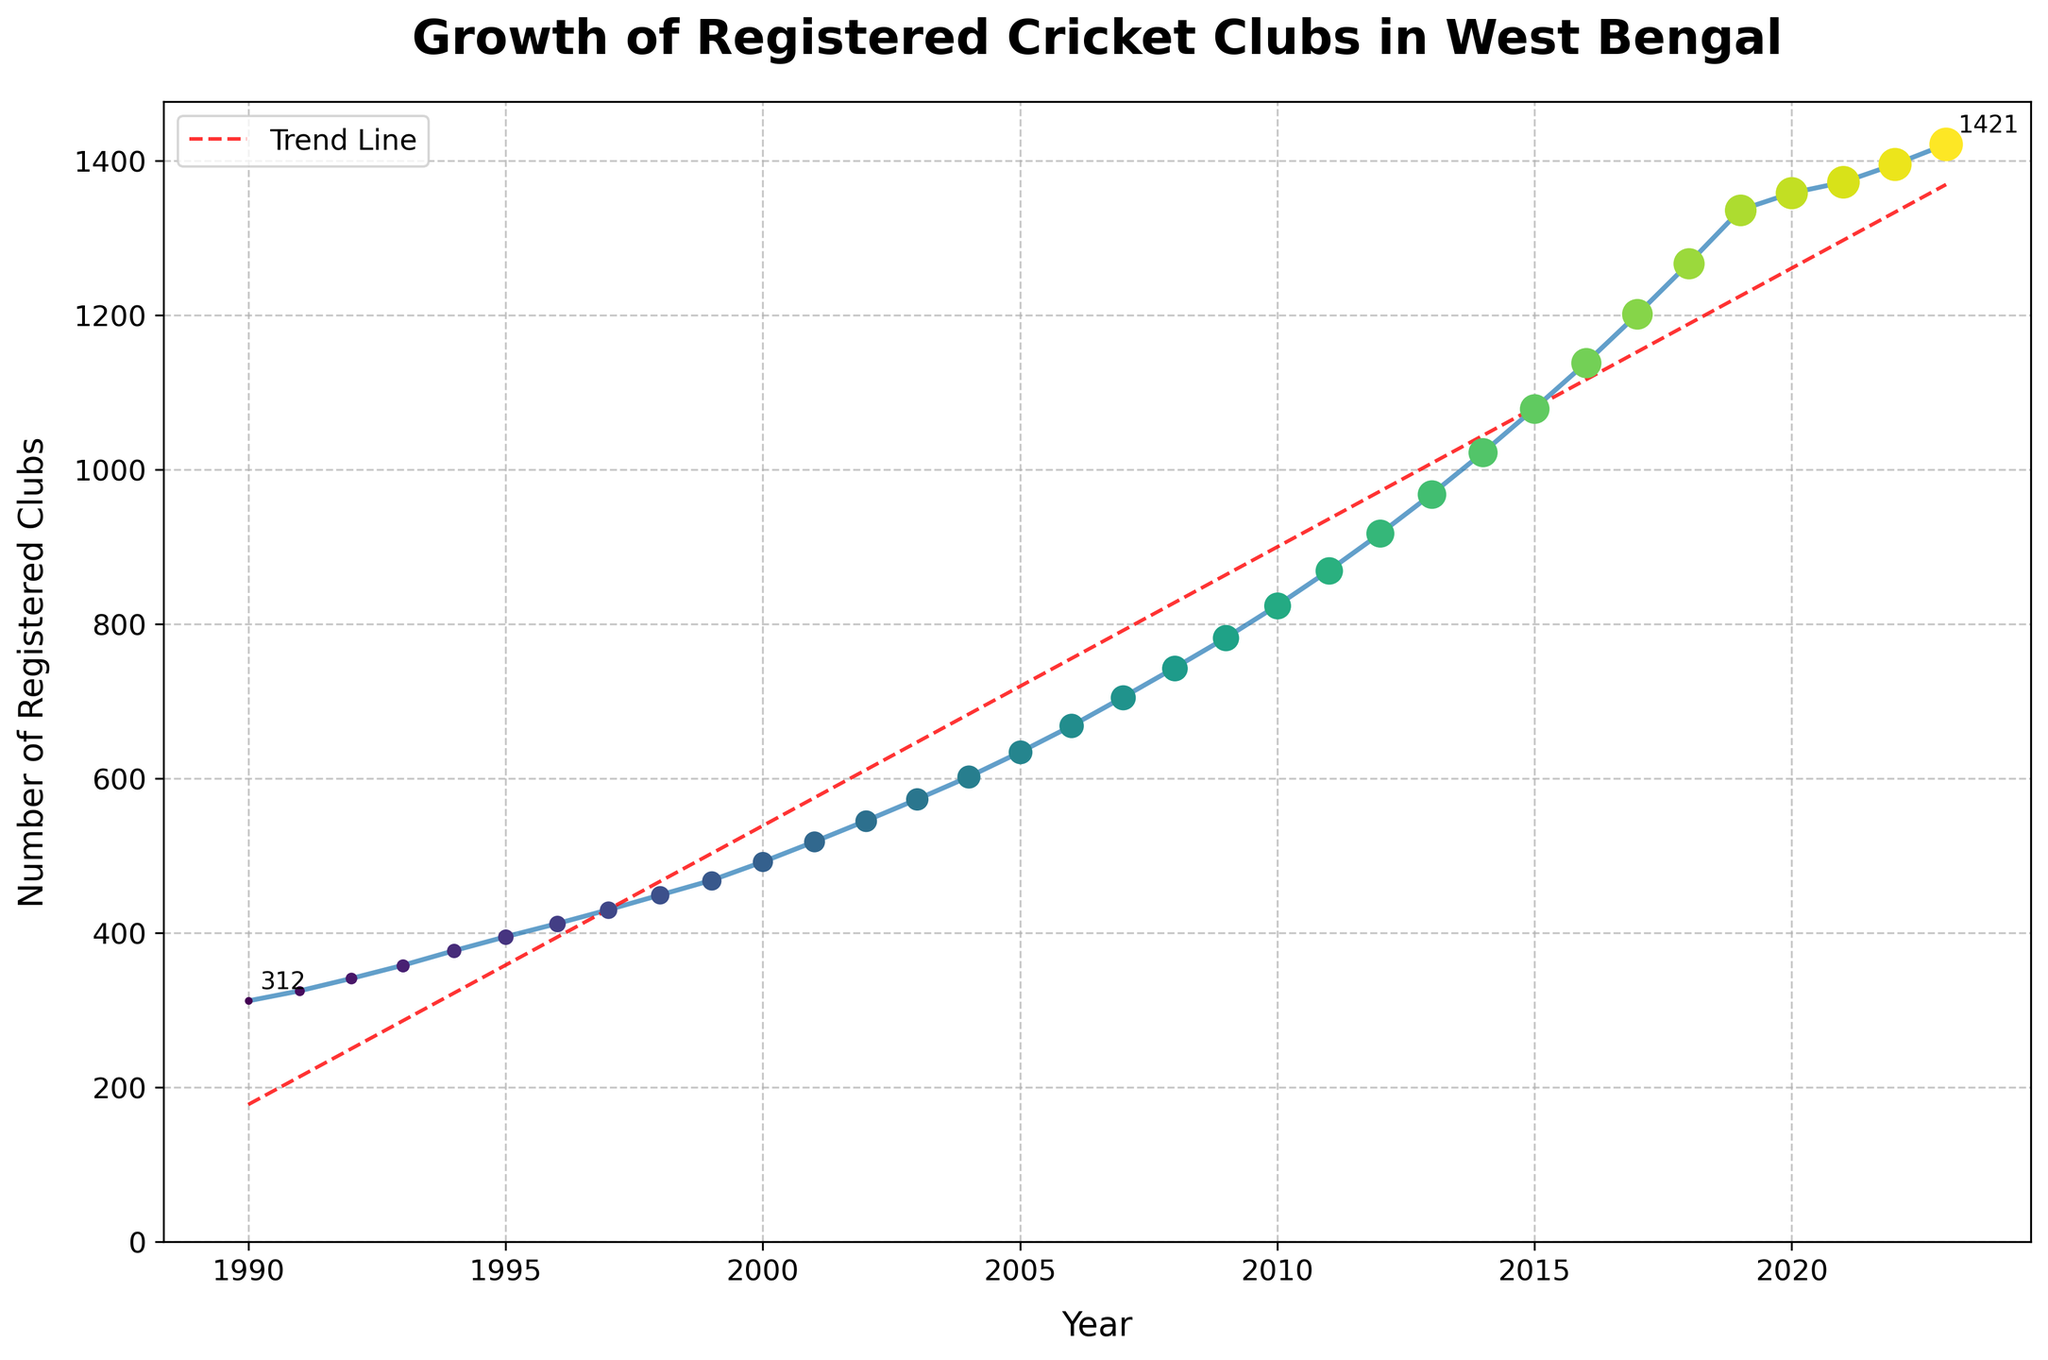What was the number of registered cricket clubs in West Bengal in 1995? To answer this, look at the data point corresponding to the year 1995. The plot shows 395 clubs in 1995.
Answer: 395 What is the percentage growth in the number of registered cricket clubs from 1990 to 2023? Calculate the increase: 1421 - 312 = 1109. Then, divide by the initial number and multiply by 100 to get the percentage: (1109 / 312) * 100 ≈ 355.4%.
Answer: 355.4% Which year saw the highest annual increase in the number of registered cricket clubs? To find the highest annual increase, look at the differences between consecutive years on the plot. The largest difference appears between 2013 (968 clubs) and 2014 (1022 clubs), which is an increase of 54 clubs.
Answer: 2014 How does the trend line compare to the actual data points in terms of the overall growth rate? The trend line generally follows the upward trajectory of the data points, indicating a consistent increase in the number of clubs over the years. Both the line and the data points suggest significant growth, albeit with some variance around the trend line.
Answer: Consistent upward growth What was the average number of registered cricket clubs between 2000 and 2010? Sum the number of clubs for each year between 2000 and 2010: 492, 518, 545, 573, 602, 634, 668, 705, 743, 782, 824. This sums to 7286. There are 11 years, so the average is 7286 / 11 ≈ 662.
Answer: 662 Compare the number of registered cricket clubs in 2005 and 2015. Which year had more, and by how much? In 2005, there were 634 clubs, and in 2015, there were 1079 clubs. The difference is 1079 - 634 = 445 more clubs in 2015.
Answer: 2015, by 445 clubs Between which consecutive years was there the slowest growth in the number of registered cricket clubs? Look for the smallest difference between consecutive years. Between 2020 (1358) and 2021 (1372), the increase is only 14 clubs, which is the smallest annual increase.
Answer: 2020-2021 What is the overall trend in the number of registered cricket clubs from 1990 to 2023, as shown by the trend line? The trend line shows a steady, linear increase over the entire period from 1990 to 2023, indicating consistent growth in the number of registered cricket clubs each year.
Answer: Steady linear increase 